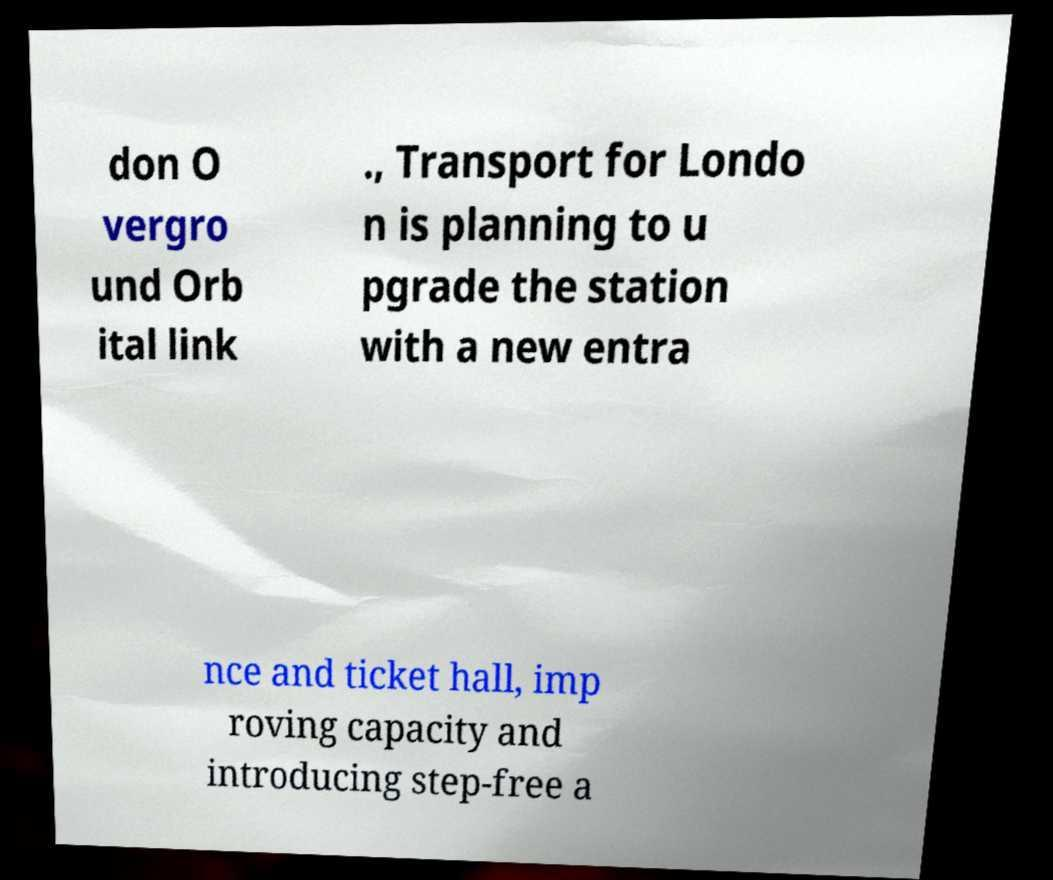Can you read and provide the text displayed in the image?This photo seems to have some interesting text. Can you extract and type it out for me? don O vergro und Orb ital link ., Transport for Londo n is planning to u pgrade the station with a new entra nce and ticket hall, imp roving capacity and introducing step-free a 